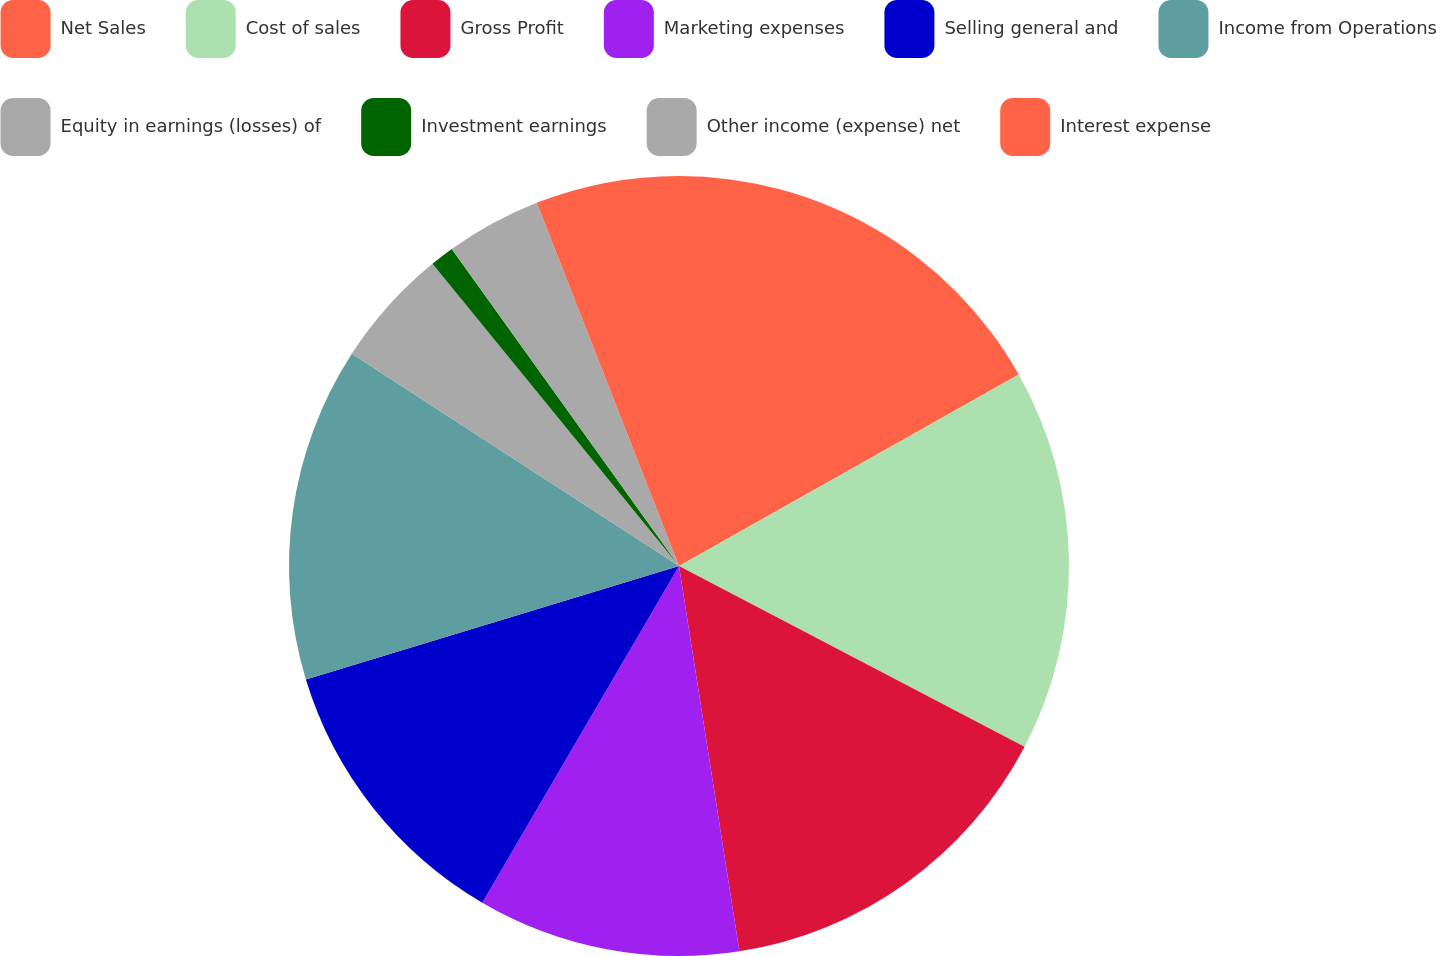Convert chart. <chart><loc_0><loc_0><loc_500><loc_500><pie_chart><fcel>Net Sales<fcel>Cost of sales<fcel>Gross Profit<fcel>Marketing expenses<fcel>Selling general and<fcel>Income from Operations<fcel>Equity in earnings (losses) of<fcel>Investment earnings<fcel>Other income (expense) net<fcel>Interest expense<nl><fcel>16.83%<fcel>15.84%<fcel>14.85%<fcel>10.89%<fcel>11.88%<fcel>13.86%<fcel>4.95%<fcel>0.99%<fcel>3.96%<fcel>5.94%<nl></chart> 